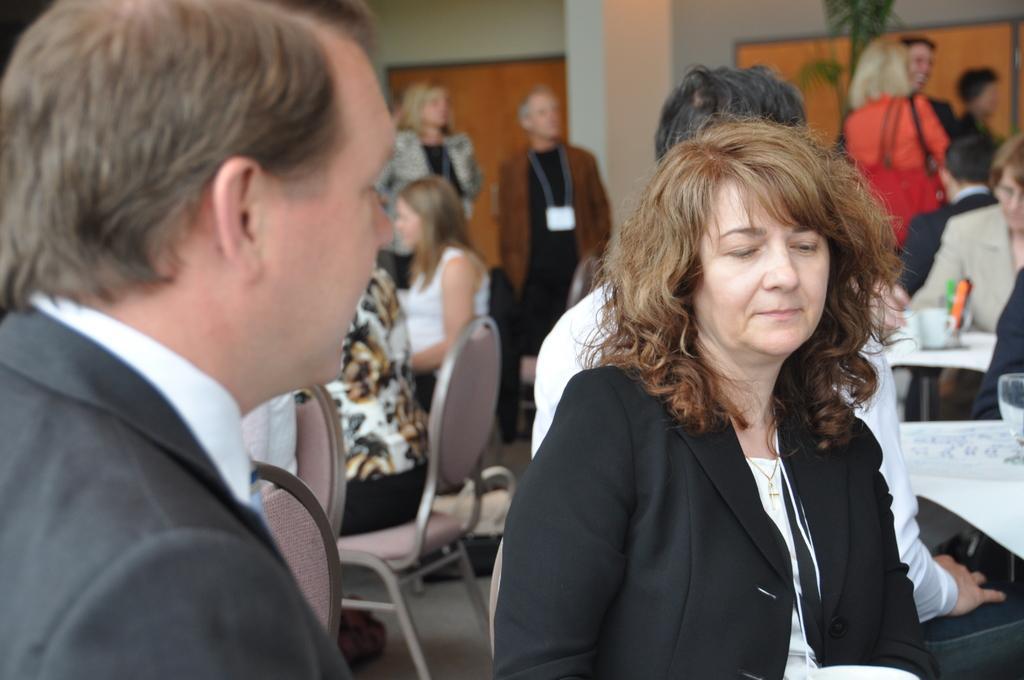Can you describe this image briefly? This image consists of many people. In the front, there is a woman and a man wearing black suits. In the background, there are many people sitting in the chairs. And there are tables covered with white clothes. 